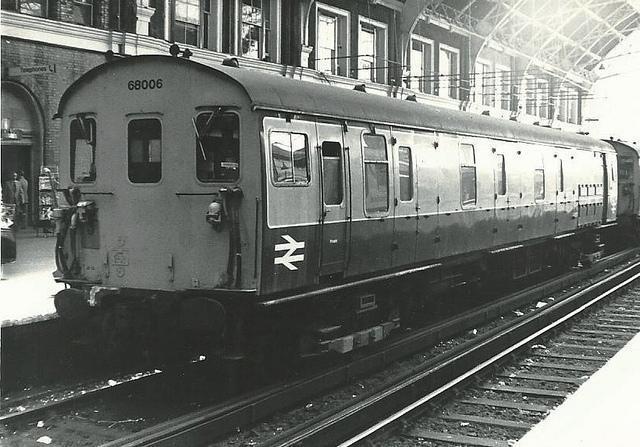How many trains can be seen?
Give a very brief answer. 1. 